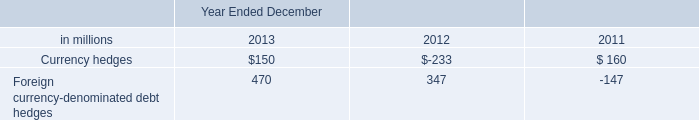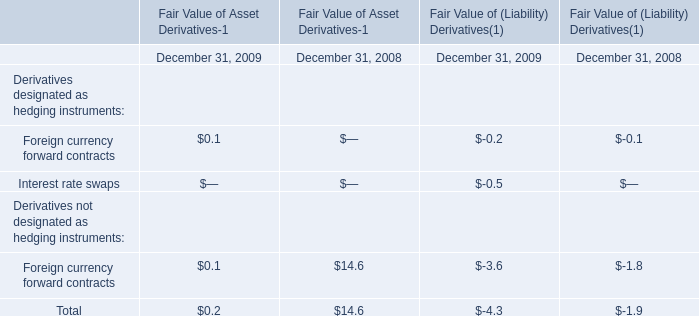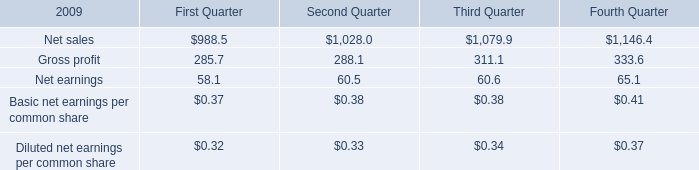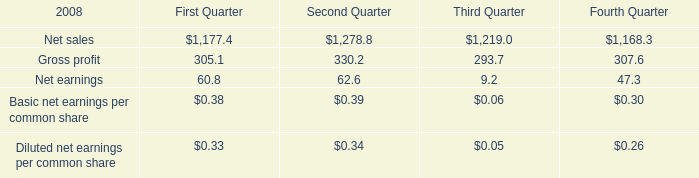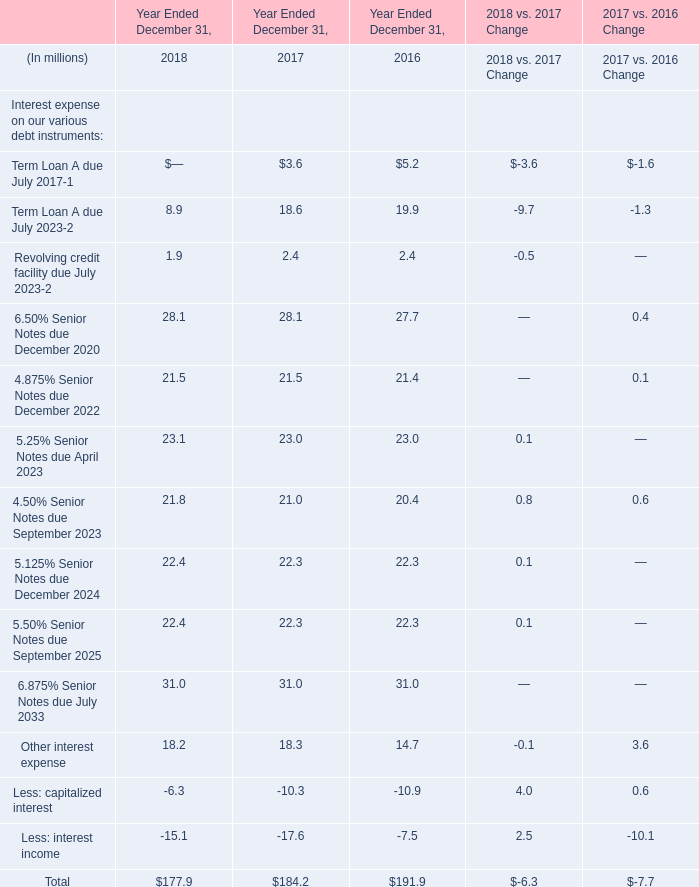What's the growing rate of Other interest expense in 2018 Ended December 31? 
Computations: ((18.2 - 18.3) / 18.3)
Answer: -0.00546. 